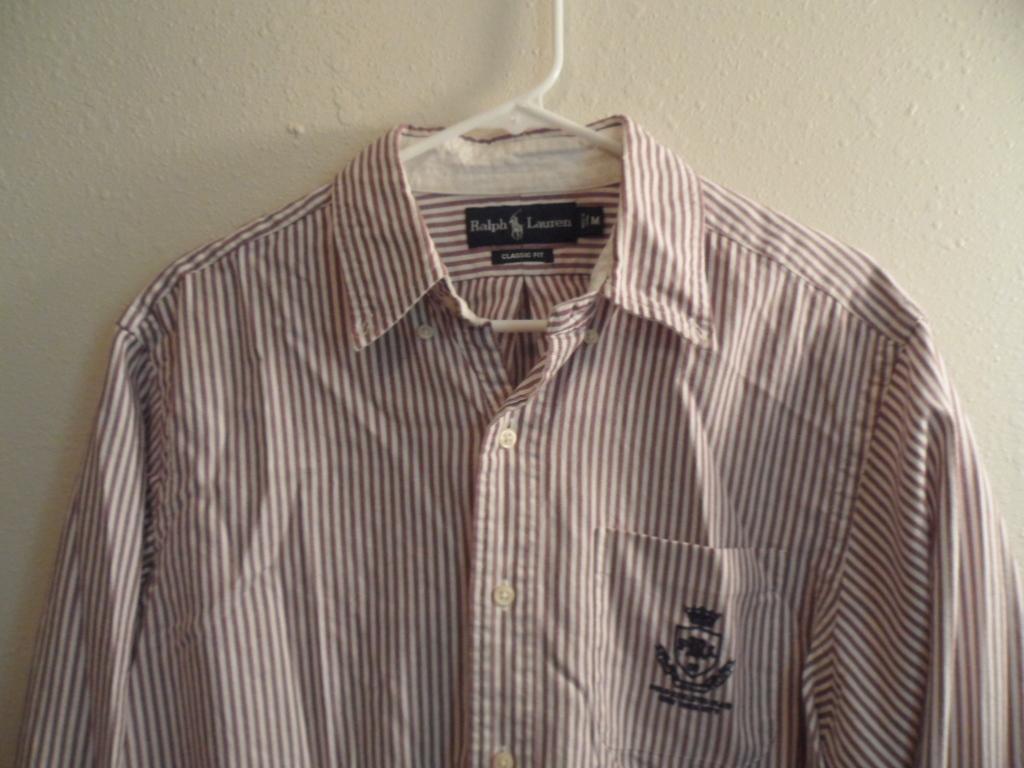How would you summarize this image in a sentence or two? In this image I can see a shirt which is white and maroon in color is hanged to the cream colored wall with a hanger which is white in color. 